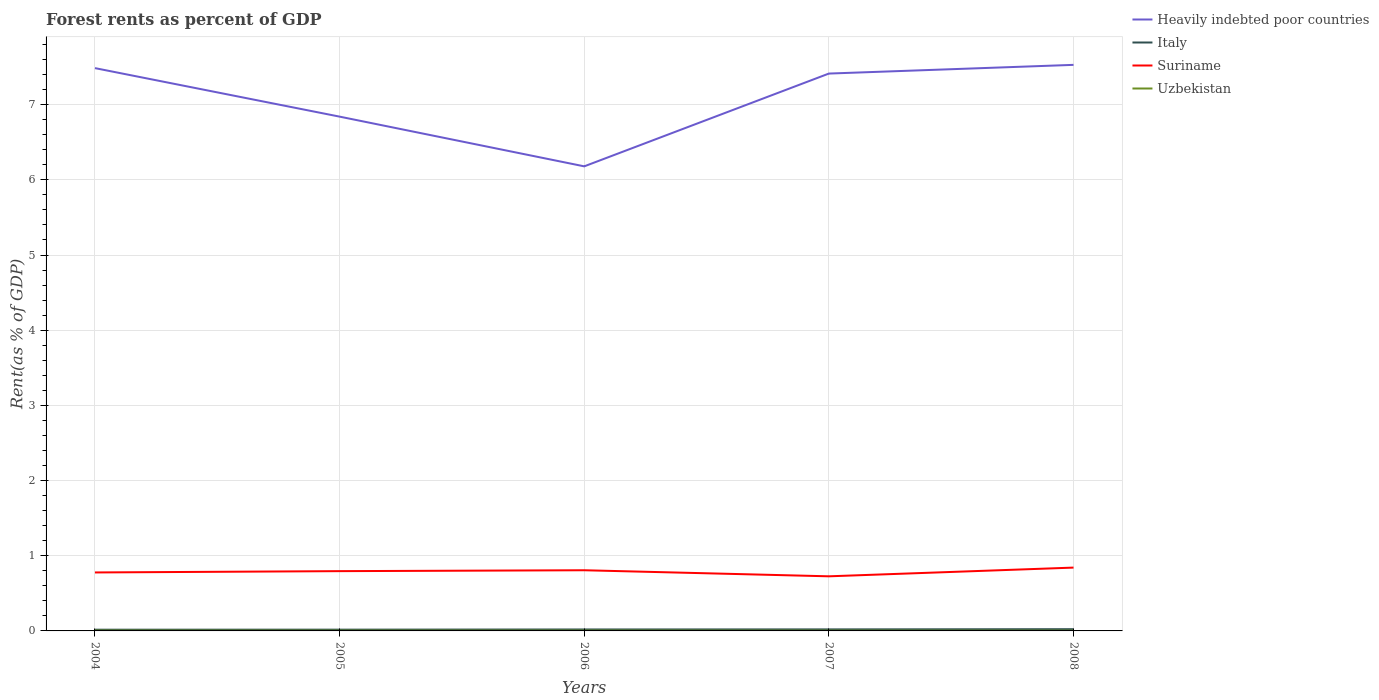Does the line corresponding to Italy intersect with the line corresponding to Suriname?
Your answer should be compact. No. Across all years, what is the maximum forest rent in Suriname?
Your answer should be very brief. 0.73. In which year was the forest rent in Heavily indebted poor countries maximum?
Ensure brevity in your answer.  2006. What is the total forest rent in Heavily indebted poor countries in the graph?
Your answer should be very brief. 1.31. What is the difference between the highest and the second highest forest rent in Italy?
Offer a very short reply. 0.01. What is the difference between the highest and the lowest forest rent in Uzbekistan?
Your answer should be very brief. 2. Is the forest rent in Uzbekistan strictly greater than the forest rent in Italy over the years?
Your response must be concise. Yes. How are the legend labels stacked?
Offer a very short reply. Vertical. What is the title of the graph?
Give a very brief answer. Forest rents as percent of GDP. What is the label or title of the Y-axis?
Offer a very short reply. Rent(as % of GDP). What is the Rent(as % of GDP) of Heavily indebted poor countries in 2004?
Give a very brief answer. 7.49. What is the Rent(as % of GDP) in Italy in 2004?
Make the answer very short. 0.02. What is the Rent(as % of GDP) of Suriname in 2004?
Your response must be concise. 0.78. What is the Rent(as % of GDP) of Uzbekistan in 2004?
Your response must be concise. 0. What is the Rent(as % of GDP) of Heavily indebted poor countries in 2005?
Provide a short and direct response. 6.84. What is the Rent(as % of GDP) of Italy in 2005?
Offer a terse response. 0.02. What is the Rent(as % of GDP) of Suriname in 2005?
Give a very brief answer. 0.8. What is the Rent(as % of GDP) of Uzbekistan in 2005?
Offer a terse response. 0. What is the Rent(as % of GDP) in Heavily indebted poor countries in 2006?
Your answer should be compact. 6.18. What is the Rent(as % of GDP) of Italy in 2006?
Your answer should be compact. 0.02. What is the Rent(as % of GDP) of Suriname in 2006?
Provide a succinct answer. 0.81. What is the Rent(as % of GDP) in Uzbekistan in 2006?
Your answer should be very brief. 0. What is the Rent(as % of GDP) in Heavily indebted poor countries in 2007?
Give a very brief answer. 7.41. What is the Rent(as % of GDP) of Italy in 2007?
Your answer should be very brief. 0.02. What is the Rent(as % of GDP) of Suriname in 2007?
Give a very brief answer. 0.73. What is the Rent(as % of GDP) of Uzbekistan in 2007?
Make the answer very short. 0. What is the Rent(as % of GDP) of Heavily indebted poor countries in 2008?
Your answer should be very brief. 7.53. What is the Rent(as % of GDP) in Italy in 2008?
Ensure brevity in your answer.  0.02. What is the Rent(as % of GDP) of Suriname in 2008?
Your answer should be compact. 0.84. What is the Rent(as % of GDP) of Uzbekistan in 2008?
Make the answer very short. 0. Across all years, what is the maximum Rent(as % of GDP) in Heavily indebted poor countries?
Provide a succinct answer. 7.53. Across all years, what is the maximum Rent(as % of GDP) in Italy?
Your answer should be very brief. 0.02. Across all years, what is the maximum Rent(as % of GDP) in Suriname?
Offer a terse response. 0.84. Across all years, what is the maximum Rent(as % of GDP) of Uzbekistan?
Make the answer very short. 0. Across all years, what is the minimum Rent(as % of GDP) in Heavily indebted poor countries?
Offer a very short reply. 6.18. Across all years, what is the minimum Rent(as % of GDP) in Italy?
Offer a very short reply. 0.02. Across all years, what is the minimum Rent(as % of GDP) of Suriname?
Your response must be concise. 0.73. Across all years, what is the minimum Rent(as % of GDP) of Uzbekistan?
Your response must be concise. 0. What is the total Rent(as % of GDP) of Heavily indebted poor countries in the graph?
Your answer should be very brief. 35.45. What is the total Rent(as % of GDP) in Italy in the graph?
Give a very brief answer. 0.1. What is the total Rent(as % of GDP) of Suriname in the graph?
Give a very brief answer. 3.95. What is the total Rent(as % of GDP) of Uzbekistan in the graph?
Offer a very short reply. 0.02. What is the difference between the Rent(as % of GDP) of Heavily indebted poor countries in 2004 and that in 2005?
Keep it short and to the point. 0.65. What is the difference between the Rent(as % of GDP) of Italy in 2004 and that in 2005?
Give a very brief answer. -0. What is the difference between the Rent(as % of GDP) of Suriname in 2004 and that in 2005?
Keep it short and to the point. -0.02. What is the difference between the Rent(as % of GDP) in Uzbekistan in 2004 and that in 2005?
Provide a short and direct response. 0. What is the difference between the Rent(as % of GDP) in Heavily indebted poor countries in 2004 and that in 2006?
Keep it short and to the point. 1.31. What is the difference between the Rent(as % of GDP) of Italy in 2004 and that in 2006?
Offer a terse response. -0. What is the difference between the Rent(as % of GDP) of Suriname in 2004 and that in 2006?
Your answer should be very brief. -0.03. What is the difference between the Rent(as % of GDP) of Uzbekistan in 2004 and that in 2006?
Your answer should be very brief. 0. What is the difference between the Rent(as % of GDP) of Heavily indebted poor countries in 2004 and that in 2007?
Your response must be concise. 0.07. What is the difference between the Rent(as % of GDP) of Italy in 2004 and that in 2007?
Your answer should be very brief. -0. What is the difference between the Rent(as % of GDP) of Suriname in 2004 and that in 2007?
Provide a succinct answer. 0.05. What is the difference between the Rent(as % of GDP) in Uzbekistan in 2004 and that in 2007?
Provide a succinct answer. 0. What is the difference between the Rent(as % of GDP) in Heavily indebted poor countries in 2004 and that in 2008?
Your response must be concise. -0.04. What is the difference between the Rent(as % of GDP) in Italy in 2004 and that in 2008?
Provide a succinct answer. -0.01. What is the difference between the Rent(as % of GDP) in Suriname in 2004 and that in 2008?
Offer a very short reply. -0.06. What is the difference between the Rent(as % of GDP) in Uzbekistan in 2004 and that in 2008?
Keep it short and to the point. 0. What is the difference between the Rent(as % of GDP) in Heavily indebted poor countries in 2005 and that in 2006?
Offer a terse response. 0.66. What is the difference between the Rent(as % of GDP) of Italy in 2005 and that in 2006?
Keep it short and to the point. -0. What is the difference between the Rent(as % of GDP) of Suriname in 2005 and that in 2006?
Ensure brevity in your answer.  -0.01. What is the difference between the Rent(as % of GDP) of Uzbekistan in 2005 and that in 2006?
Provide a succinct answer. -0. What is the difference between the Rent(as % of GDP) of Heavily indebted poor countries in 2005 and that in 2007?
Ensure brevity in your answer.  -0.57. What is the difference between the Rent(as % of GDP) of Italy in 2005 and that in 2007?
Your answer should be compact. -0. What is the difference between the Rent(as % of GDP) in Suriname in 2005 and that in 2007?
Ensure brevity in your answer.  0.07. What is the difference between the Rent(as % of GDP) of Uzbekistan in 2005 and that in 2007?
Your answer should be very brief. 0. What is the difference between the Rent(as % of GDP) in Heavily indebted poor countries in 2005 and that in 2008?
Your answer should be very brief. -0.69. What is the difference between the Rent(as % of GDP) of Italy in 2005 and that in 2008?
Ensure brevity in your answer.  -0.01. What is the difference between the Rent(as % of GDP) in Suriname in 2005 and that in 2008?
Offer a very short reply. -0.05. What is the difference between the Rent(as % of GDP) of Uzbekistan in 2005 and that in 2008?
Offer a terse response. 0. What is the difference between the Rent(as % of GDP) in Heavily indebted poor countries in 2006 and that in 2007?
Make the answer very short. -1.23. What is the difference between the Rent(as % of GDP) in Italy in 2006 and that in 2007?
Provide a short and direct response. -0. What is the difference between the Rent(as % of GDP) of Suriname in 2006 and that in 2007?
Offer a very short reply. 0.08. What is the difference between the Rent(as % of GDP) in Uzbekistan in 2006 and that in 2007?
Offer a very short reply. 0. What is the difference between the Rent(as % of GDP) of Heavily indebted poor countries in 2006 and that in 2008?
Your answer should be compact. -1.35. What is the difference between the Rent(as % of GDP) in Italy in 2006 and that in 2008?
Your answer should be compact. -0. What is the difference between the Rent(as % of GDP) in Suriname in 2006 and that in 2008?
Offer a terse response. -0.04. What is the difference between the Rent(as % of GDP) of Uzbekistan in 2006 and that in 2008?
Make the answer very short. 0. What is the difference between the Rent(as % of GDP) of Heavily indebted poor countries in 2007 and that in 2008?
Offer a terse response. -0.12. What is the difference between the Rent(as % of GDP) of Italy in 2007 and that in 2008?
Keep it short and to the point. -0. What is the difference between the Rent(as % of GDP) in Suriname in 2007 and that in 2008?
Offer a terse response. -0.12. What is the difference between the Rent(as % of GDP) in Uzbekistan in 2007 and that in 2008?
Keep it short and to the point. 0. What is the difference between the Rent(as % of GDP) of Heavily indebted poor countries in 2004 and the Rent(as % of GDP) of Italy in 2005?
Offer a very short reply. 7.47. What is the difference between the Rent(as % of GDP) in Heavily indebted poor countries in 2004 and the Rent(as % of GDP) in Suriname in 2005?
Give a very brief answer. 6.69. What is the difference between the Rent(as % of GDP) in Heavily indebted poor countries in 2004 and the Rent(as % of GDP) in Uzbekistan in 2005?
Give a very brief answer. 7.48. What is the difference between the Rent(as % of GDP) in Italy in 2004 and the Rent(as % of GDP) in Suriname in 2005?
Make the answer very short. -0.78. What is the difference between the Rent(as % of GDP) of Italy in 2004 and the Rent(as % of GDP) of Uzbekistan in 2005?
Your response must be concise. 0.01. What is the difference between the Rent(as % of GDP) of Suriname in 2004 and the Rent(as % of GDP) of Uzbekistan in 2005?
Your response must be concise. 0.77. What is the difference between the Rent(as % of GDP) in Heavily indebted poor countries in 2004 and the Rent(as % of GDP) in Italy in 2006?
Offer a very short reply. 7.47. What is the difference between the Rent(as % of GDP) of Heavily indebted poor countries in 2004 and the Rent(as % of GDP) of Suriname in 2006?
Ensure brevity in your answer.  6.68. What is the difference between the Rent(as % of GDP) of Heavily indebted poor countries in 2004 and the Rent(as % of GDP) of Uzbekistan in 2006?
Your answer should be very brief. 7.48. What is the difference between the Rent(as % of GDP) in Italy in 2004 and the Rent(as % of GDP) in Suriname in 2006?
Provide a short and direct response. -0.79. What is the difference between the Rent(as % of GDP) of Italy in 2004 and the Rent(as % of GDP) of Uzbekistan in 2006?
Offer a terse response. 0.01. What is the difference between the Rent(as % of GDP) of Suriname in 2004 and the Rent(as % of GDP) of Uzbekistan in 2006?
Provide a succinct answer. 0.77. What is the difference between the Rent(as % of GDP) of Heavily indebted poor countries in 2004 and the Rent(as % of GDP) of Italy in 2007?
Provide a short and direct response. 7.47. What is the difference between the Rent(as % of GDP) in Heavily indebted poor countries in 2004 and the Rent(as % of GDP) in Suriname in 2007?
Give a very brief answer. 6.76. What is the difference between the Rent(as % of GDP) in Heavily indebted poor countries in 2004 and the Rent(as % of GDP) in Uzbekistan in 2007?
Make the answer very short. 7.48. What is the difference between the Rent(as % of GDP) of Italy in 2004 and the Rent(as % of GDP) of Suriname in 2007?
Give a very brief answer. -0.71. What is the difference between the Rent(as % of GDP) of Italy in 2004 and the Rent(as % of GDP) of Uzbekistan in 2007?
Give a very brief answer. 0.01. What is the difference between the Rent(as % of GDP) of Suriname in 2004 and the Rent(as % of GDP) of Uzbekistan in 2007?
Offer a terse response. 0.77. What is the difference between the Rent(as % of GDP) of Heavily indebted poor countries in 2004 and the Rent(as % of GDP) of Italy in 2008?
Offer a very short reply. 7.46. What is the difference between the Rent(as % of GDP) of Heavily indebted poor countries in 2004 and the Rent(as % of GDP) of Suriname in 2008?
Offer a very short reply. 6.64. What is the difference between the Rent(as % of GDP) of Heavily indebted poor countries in 2004 and the Rent(as % of GDP) of Uzbekistan in 2008?
Give a very brief answer. 7.48. What is the difference between the Rent(as % of GDP) in Italy in 2004 and the Rent(as % of GDP) in Suriname in 2008?
Give a very brief answer. -0.83. What is the difference between the Rent(as % of GDP) of Italy in 2004 and the Rent(as % of GDP) of Uzbekistan in 2008?
Offer a very short reply. 0.01. What is the difference between the Rent(as % of GDP) in Suriname in 2004 and the Rent(as % of GDP) in Uzbekistan in 2008?
Offer a terse response. 0.77. What is the difference between the Rent(as % of GDP) in Heavily indebted poor countries in 2005 and the Rent(as % of GDP) in Italy in 2006?
Offer a terse response. 6.82. What is the difference between the Rent(as % of GDP) in Heavily indebted poor countries in 2005 and the Rent(as % of GDP) in Suriname in 2006?
Offer a terse response. 6.03. What is the difference between the Rent(as % of GDP) in Heavily indebted poor countries in 2005 and the Rent(as % of GDP) in Uzbekistan in 2006?
Provide a succinct answer. 6.84. What is the difference between the Rent(as % of GDP) in Italy in 2005 and the Rent(as % of GDP) in Suriname in 2006?
Your response must be concise. -0.79. What is the difference between the Rent(as % of GDP) in Italy in 2005 and the Rent(as % of GDP) in Uzbekistan in 2006?
Provide a short and direct response. 0.01. What is the difference between the Rent(as % of GDP) in Suriname in 2005 and the Rent(as % of GDP) in Uzbekistan in 2006?
Provide a short and direct response. 0.79. What is the difference between the Rent(as % of GDP) in Heavily indebted poor countries in 2005 and the Rent(as % of GDP) in Italy in 2007?
Your answer should be compact. 6.82. What is the difference between the Rent(as % of GDP) in Heavily indebted poor countries in 2005 and the Rent(as % of GDP) in Suriname in 2007?
Your response must be concise. 6.11. What is the difference between the Rent(as % of GDP) in Heavily indebted poor countries in 2005 and the Rent(as % of GDP) in Uzbekistan in 2007?
Your response must be concise. 6.84. What is the difference between the Rent(as % of GDP) in Italy in 2005 and the Rent(as % of GDP) in Suriname in 2007?
Provide a succinct answer. -0.71. What is the difference between the Rent(as % of GDP) of Italy in 2005 and the Rent(as % of GDP) of Uzbekistan in 2007?
Provide a succinct answer. 0.01. What is the difference between the Rent(as % of GDP) in Suriname in 2005 and the Rent(as % of GDP) in Uzbekistan in 2007?
Keep it short and to the point. 0.79. What is the difference between the Rent(as % of GDP) in Heavily indebted poor countries in 2005 and the Rent(as % of GDP) in Italy in 2008?
Your response must be concise. 6.82. What is the difference between the Rent(as % of GDP) of Heavily indebted poor countries in 2005 and the Rent(as % of GDP) of Suriname in 2008?
Provide a short and direct response. 6. What is the difference between the Rent(as % of GDP) of Heavily indebted poor countries in 2005 and the Rent(as % of GDP) of Uzbekistan in 2008?
Your answer should be compact. 6.84. What is the difference between the Rent(as % of GDP) in Italy in 2005 and the Rent(as % of GDP) in Suriname in 2008?
Your response must be concise. -0.83. What is the difference between the Rent(as % of GDP) in Italy in 2005 and the Rent(as % of GDP) in Uzbekistan in 2008?
Keep it short and to the point. 0.01. What is the difference between the Rent(as % of GDP) in Suriname in 2005 and the Rent(as % of GDP) in Uzbekistan in 2008?
Offer a terse response. 0.79. What is the difference between the Rent(as % of GDP) of Heavily indebted poor countries in 2006 and the Rent(as % of GDP) of Italy in 2007?
Ensure brevity in your answer.  6.16. What is the difference between the Rent(as % of GDP) in Heavily indebted poor countries in 2006 and the Rent(as % of GDP) in Suriname in 2007?
Your answer should be compact. 5.45. What is the difference between the Rent(as % of GDP) of Heavily indebted poor countries in 2006 and the Rent(as % of GDP) of Uzbekistan in 2007?
Ensure brevity in your answer.  6.18. What is the difference between the Rent(as % of GDP) in Italy in 2006 and the Rent(as % of GDP) in Suriname in 2007?
Your response must be concise. -0.71. What is the difference between the Rent(as % of GDP) of Italy in 2006 and the Rent(as % of GDP) of Uzbekistan in 2007?
Give a very brief answer. 0.02. What is the difference between the Rent(as % of GDP) of Suriname in 2006 and the Rent(as % of GDP) of Uzbekistan in 2007?
Offer a terse response. 0.8. What is the difference between the Rent(as % of GDP) of Heavily indebted poor countries in 2006 and the Rent(as % of GDP) of Italy in 2008?
Offer a very short reply. 6.16. What is the difference between the Rent(as % of GDP) of Heavily indebted poor countries in 2006 and the Rent(as % of GDP) of Suriname in 2008?
Make the answer very short. 5.34. What is the difference between the Rent(as % of GDP) in Heavily indebted poor countries in 2006 and the Rent(as % of GDP) in Uzbekistan in 2008?
Your answer should be compact. 6.18. What is the difference between the Rent(as % of GDP) in Italy in 2006 and the Rent(as % of GDP) in Suriname in 2008?
Your answer should be compact. -0.82. What is the difference between the Rent(as % of GDP) of Italy in 2006 and the Rent(as % of GDP) of Uzbekistan in 2008?
Provide a succinct answer. 0.02. What is the difference between the Rent(as % of GDP) of Suriname in 2006 and the Rent(as % of GDP) of Uzbekistan in 2008?
Offer a very short reply. 0.8. What is the difference between the Rent(as % of GDP) in Heavily indebted poor countries in 2007 and the Rent(as % of GDP) in Italy in 2008?
Your answer should be very brief. 7.39. What is the difference between the Rent(as % of GDP) in Heavily indebted poor countries in 2007 and the Rent(as % of GDP) in Suriname in 2008?
Offer a terse response. 6.57. What is the difference between the Rent(as % of GDP) in Heavily indebted poor countries in 2007 and the Rent(as % of GDP) in Uzbekistan in 2008?
Your response must be concise. 7.41. What is the difference between the Rent(as % of GDP) of Italy in 2007 and the Rent(as % of GDP) of Suriname in 2008?
Your answer should be very brief. -0.82. What is the difference between the Rent(as % of GDP) of Italy in 2007 and the Rent(as % of GDP) of Uzbekistan in 2008?
Your answer should be compact. 0.02. What is the difference between the Rent(as % of GDP) in Suriname in 2007 and the Rent(as % of GDP) in Uzbekistan in 2008?
Your answer should be very brief. 0.72. What is the average Rent(as % of GDP) in Heavily indebted poor countries per year?
Offer a terse response. 7.09. What is the average Rent(as % of GDP) of Italy per year?
Offer a terse response. 0.02. What is the average Rent(as % of GDP) in Suriname per year?
Make the answer very short. 0.79. What is the average Rent(as % of GDP) of Uzbekistan per year?
Offer a terse response. 0. In the year 2004, what is the difference between the Rent(as % of GDP) in Heavily indebted poor countries and Rent(as % of GDP) in Italy?
Make the answer very short. 7.47. In the year 2004, what is the difference between the Rent(as % of GDP) in Heavily indebted poor countries and Rent(as % of GDP) in Suriname?
Keep it short and to the point. 6.71. In the year 2004, what is the difference between the Rent(as % of GDP) in Heavily indebted poor countries and Rent(as % of GDP) in Uzbekistan?
Make the answer very short. 7.48. In the year 2004, what is the difference between the Rent(as % of GDP) of Italy and Rent(as % of GDP) of Suriname?
Make the answer very short. -0.76. In the year 2004, what is the difference between the Rent(as % of GDP) of Italy and Rent(as % of GDP) of Uzbekistan?
Your response must be concise. 0.01. In the year 2004, what is the difference between the Rent(as % of GDP) in Suriname and Rent(as % of GDP) in Uzbekistan?
Your response must be concise. 0.77. In the year 2005, what is the difference between the Rent(as % of GDP) in Heavily indebted poor countries and Rent(as % of GDP) in Italy?
Provide a succinct answer. 6.82. In the year 2005, what is the difference between the Rent(as % of GDP) in Heavily indebted poor countries and Rent(as % of GDP) in Suriname?
Your response must be concise. 6.05. In the year 2005, what is the difference between the Rent(as % of GDP) in Heavily indebted poor countries and Rent(as % of GDP) in Uzbekistan?
Offer a very short reply. 6.84. In the year 2005, what is the difference between the Rent(as % of GDP) of Italy and Rent(as % of GDP) of Suriname?
Your response must be concise. -0.78. In the year 2005, what is the difference between the Rent(as % of GDP) of Italy and Rent(as % of GDP) of Uzbekistan?
Your response must be concise. 0.01. In the year 2005, what is the difference between the Rent(as % of GDP) of Suriname and Rent(as % of GDP) of Uzbekistan?
Provide a succinct answer. 0.79. In the year 2006, what is the difference between the Rent(as % of GDP) of Heavily indebted poor countries and Rent(as % of GDP) of Italy?
Give a very brief answer. 6.16. In the year 2006, what is the difference between the Rent(as % of GDP) in Heavily indebted poor countries and Rent(as % of GDP) in Suriname?
Ensure brevity in your answer.  5.37. In the year 2006, what is the difference between the Rent(as % of GDP) of Heavily indebted poor countries and Rent(as % of GDP) of Uzbekistan?
Your response must be concise. 6.17. In the year 2006, what is the difference between the Rent(as % of GDP) of Italy and Rent(as % of GDP) of Suriname?
Give a very brief answer. -0.79. In the year 2006, what is the difference between the Rent(as % of GDP) in Italy and Rent(as % of GDP) in Uzbekistan?
Make the answer very short. 0.01. In the year 2006, what is the difference between the Rent(as % of GDP) in Suriname and Rent(as % of GDP) in Uzbekistan?
Offer a very short reply. 0.8. In the year 2007, what is the difference between the Rent(as % of GDP) of Heavily indebted poor countries and Rent(as % of GDP) of Italy?
Your answer should be compact. 7.39. In the year 2007, what is the difference between the Rent(as % of GDP) of Heavily indebted poor countries and Rent(as % of GDP) of Suriname?
Your answer should be compact. 6.69. In the year 2007, what is the difference between the Rent(as % of GDP) of Heavily indebted poor countries and Rent(as % of GDP) of Uzbekistan?
Make the answer very short. 7.41. In the year 2007, what is the difference between the Rent(as % of GDP) in Italy and Rent(as % of GDP) in Suriname?
Your answer should be compact. -0.71. In the year 2007, what is the difference between the Rent(as % of GDP) of Italy and Rent(as % of GDP) of Uzbekistan?
Your response must be concise. 0.02. In the year 2007, what is the difference between the Rent(as % of GDP) in Suriname and Rent(as % of GDP) in Uzbekistan?
Give a very brief answer. 0.72. In the year 2008, what is the difference between the Rent(as % of GDP) in Heavily indebted poor countries and Rent(as % of GDP) in Italy?
Keep it short and to the point. 7.51. In the year 2008, what is the difference between the Rent(as % of GDP) in Heavily indebted poor countries and Rent(as % of GDP) in Suriname?
Your answer should be very brief. 6.69. In the year 2008, what is the difference between the Rent(as % of GDP) of Heavily indebted poor countries and Rent(as % of GDP) of Uzbekistan?
Your response must be concise. 7.53. In the year 2008, what is the difference between the Rent(as % of GDP) of Italy and Rent(as % of GDP) of Suriname?
Your answer should be compact. -0.82. In the year 2008, what is the difference between the Rent(as % of GDP) of Italy and Rent(as % of GDP) of Uzbekistan?
Provide a short and direct response. 0.02. In the year 2008, what is the difference between the Rent(as % of GDP) of Suriname and Rent(as % of GDP) of Uzbekistan?
Your answer should be very brief. 0.84. What is the ratio of the Rent(as % of GDP) of Heavily indebted poor countries in 2004 to that in 2005?
Offer a very short reply. 1.09. What is the ratio of the Rent(as % of GDP) of Italy in 2004 to that in 2005?
Keep it short and to the point. 0.97. What is the ratio of the Rent(as % of GDP) of Suriname in 2004 to that in 2005?
Provide a succinct answer. 0.98. What is the ratio of the Rent(as % of GDP) of Uzbekistan in 2004 to that in 2005?
Offer a terse response. 1.13. What is the ratio of the Rent(as % of GDP) in Heavily indebted poor countries in 2004 to that in 2006?
Your response must be concise. 1.21. What is the ratio of the Rent(as % of GDP) in Italy in 2004 to that in 2006?
Your answer should be very brief. 0.84. What is the ratio of the Rent(as % of GDP) of Suriname in 2004 to that in 2006?
Provide a short and direct response. 0.96. What is the ratio of the Rent(as % of GDP) in Uzbekistan in 2004 to that in 2006?
Provide a short and direct response. 1.03. What is the ratio of the Rent(as % of GDP) of Heavily indebted poor countries in 2004 to that in 2007?
Offer a very short reply. 1.01. What is the ratio of the Rent(as % of GDP) in Italy in 2004 to that in 2007?
Your answer should be very brief. 0.8. What is the ratio of the Rent(as % of GDP) of Suriname in 2004 to that in 2007?
Make the answer very short. 1.07. What is the ratio of the Rent(as % of GDP) of Uzbekistan in 2004 to that in 2007?
Keep it short and to the point. 1.16. What is the ratio of the Rent(as % of GDP) in Heavily indebted poor countries in 2004 to that in 2008?
Offer a very short reply. 0.99. What is the ratio of the Rent(as % of GDP) of Italy in 2004 to that in 2008?
Give a very brief answer. 0.7. What is the ratio of the Rent(as % of GDP) in Suriname in 2004 to that in 2008?
Keep it short and to the point. 0.92. What is the ratio of the Rent(as % of GDP) of Uzbekistan in 2004 to that in 2008?
Keep it short and to the point. 1.23. What is the ratio of the Rent(as % of GDP) of Heavily indebted poor countries in 2005 to that in 2006?
Provide a short and direct response. 1.11. What is the ratio of the Rent(as % of GDP) of Italy in 2005 to that in 2006?
Offer a terse response. 0.87. What is the ratio of the Rent(as % of GDP) of Suriname in 2005 to that in 2006?
Provide a short and direct response. 0.99. What is the ratio of the Rent(as % of GDP) of Uzbekistan in 2005 to that in 2006?
Provide a succinct answer. 0.91. What is the ratio of the Rent(as % of GDP) of Heavily indebted poor countries in 2005 to that in 2007?
Ensure brevity in your answer.  0.92. What is the ratio of the Rent(as % of GDP) in Italy in 2005 to that in 2007?
Give a very brief answer. 0.83. What is the ratio of the Rent(as % of GDP) in Suriname in 2005 to that in 2007?
Your response must be concise. 1.09. What is the ratio of the Rent(as % of GDP) of Uzbekistan in 2005 to that in 2007?
Keep it short and to the point. 1.02. What is the ratio of the Rent(as % of GDP) of Heavily indebted poor countries in 2005 to that in 2008?
Keep it short and to the point. 0.91. What is the ratio of the Rent(as % of GDP) of Italy in 2005 to that in 2008?
Ensure brevity in your answer.  0.73. What is the ratio of the Rent(as % of GDP) of Suriname in 2005 to that in 2008?
Offer a very short reply. 0.94. What is the ratio of the Rent(as % of GDP) of Uzbekistan in 2005 to that in 2008?
Offer a very short reply. 1.09. What is the ratio of the Rent(as % of GDP) in Heavily indebted poor countries in 2006 to that in 2007?
Offer a terse response. 0.83. What is the ratio of the Rent(as % of GDP) in Italy in 2006 to that in 2007?
Give a very brief answer. 0.95. What is the ratio of the Rent(as % of GDP) in Suriname in 2006 to that in 2007?
Provide a succinct answer. 1.11. What is the ratio of the Rent(as % of GDP) of Uzbekistan in 2006 to that in 2007?
Ensure brevity in your answer.  1.12. What is the ratio of the Rent(as % of GDP) in Heavily indebted poor countries in 2006 to that in 2008?
Offer a terse response. 0.82. What is the ratio of the Rent(as % of GDP) in Italy in 2006 to that in 2008?
Provide a short and direct response. 0.84. What is the ratio of the Rent(as % of GDP) of Suriname in 2006 to that in 2008?
Make the answer very short. 0.96. What is the ratio of the Rent(as % of GDP) of Uzbekistan in 2006 to that in 2008?
Make the answer very short. 1.19. What is the ratio of the Rent(as % of GDP) in Heavily indebted poor countries in 2007 to that in 2008?
Provide a short and direct response. 0.98. What is the ratio of the Rent(as % of GDP) in Italy in 2007 to that in 2008?
Your answer should be compact. 0.88. What is the ratio of the Rent(as % of GDP) of Suriname in 2007 to that in 2008?
Your answer should be compact. 0.86. What is the ratio of the Rent(as % of GDP) in Uzbekistan in 2007 to that in 2008?
Ensure brevity in your answer.  1.07. What is the difference between the highest and the second highest Rent(as % of GDP) of Heavily indebted poor countries?
Provide a succinct answer. 0.04. What is the difference between the highest and the second highest Rent(as % of GDP) of Italy?
Your answer should be very brief. 0. What is the difference between the highest and the second highest Rent(as % of GDP) of Suriname?
Offer a very short reply. 0.04. What is the difference between the highest and the lowest Rent(as % of GDP) in Heavily indebted poor countries?
Ensure brevity in your answer.  1.35. What is the difference between the highest and the lowest Rent(as % of GDP) of Italy?
Keep it short and to the point. 0.01. What is the difference between the highest and the lowest Rent(as % of GDP) in Suriname?
Your response must be concise. 0.12. What is the difference between the highest and the lowest Rent(as % of GDP) of Uzbekistan?
Provide a short and direct response. 0. 